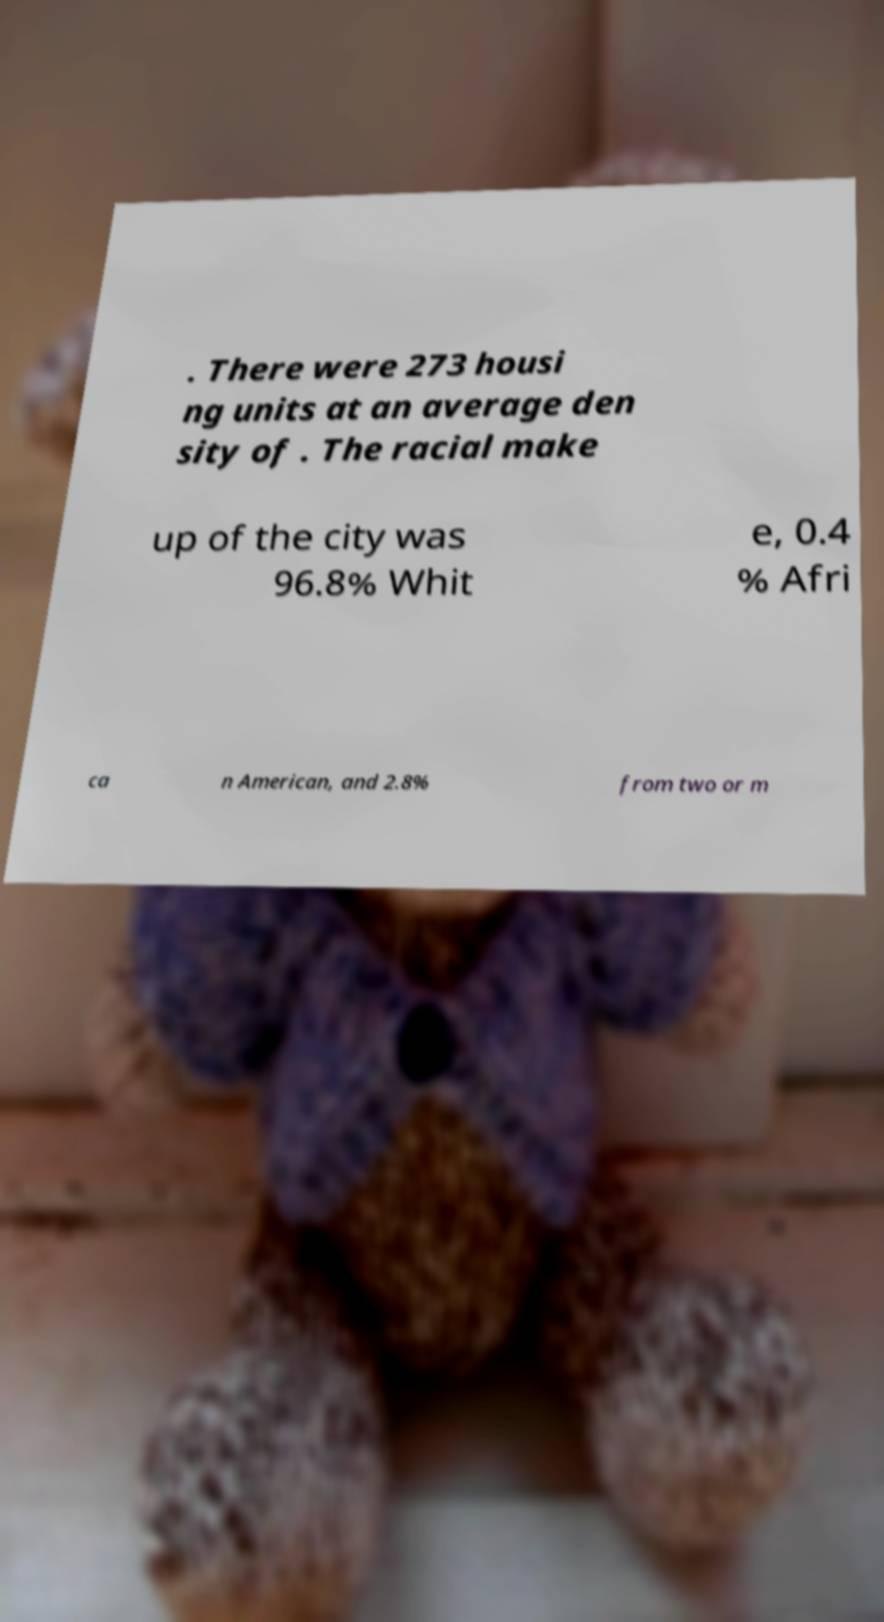Please identify and transcribe the text found in this image. . There were 273 housi ng units at an average den sity of . The racial make up of the city was 96.8% Whit e, 0.4 % Afri ca n American, and 2.8% from two or m 